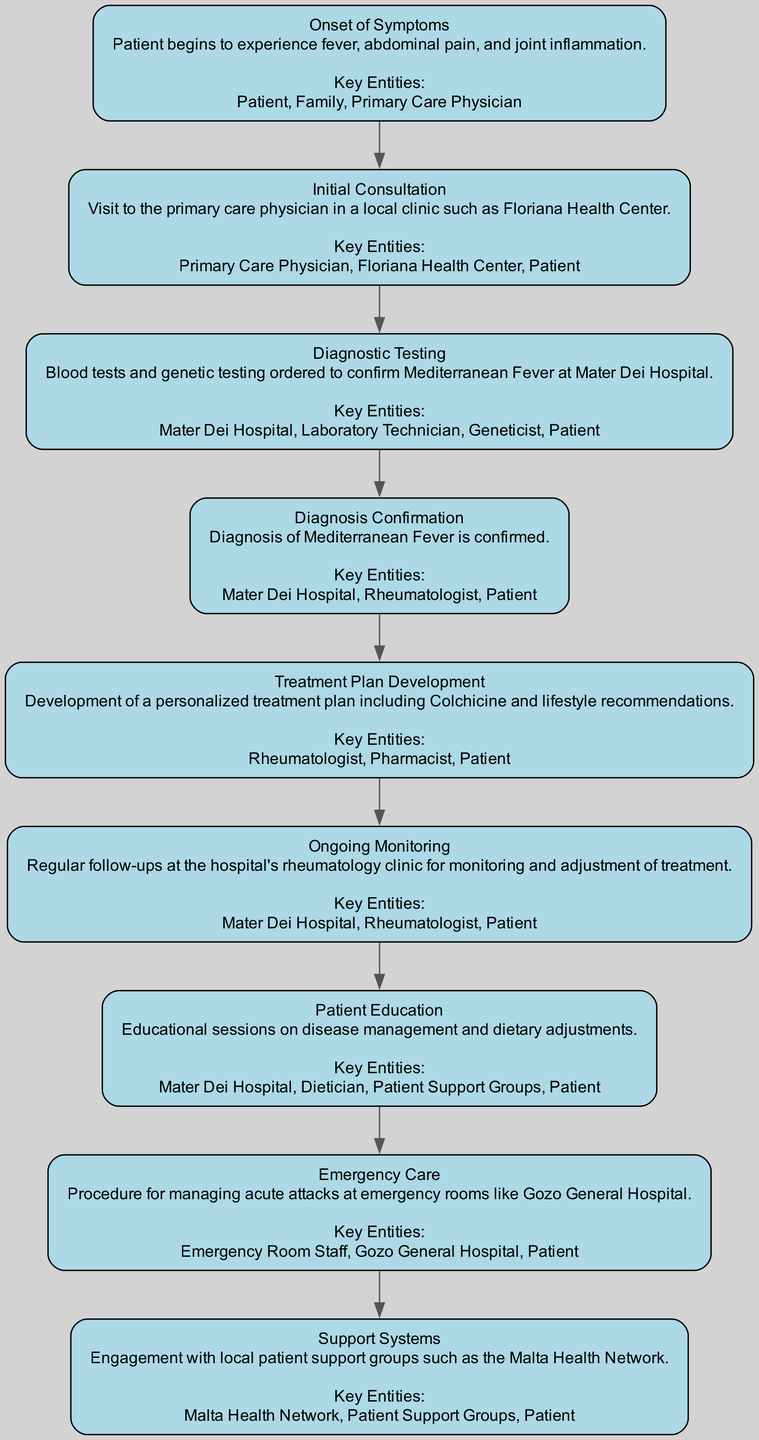What is the first step in the patient's journey? The first step listed in the diagram is "Onset of Symptoms," which describes the initial stage where the patient begins to experience fever, abdominal pain, and joint inflammation.
Answer: Onset of Symptoms How many key entities are involved in the "Initial Consultation"? The "Initial Consultation" stage mentions three key entities: the Primary Care Physician, Floriana Health Center, and Patient. Counting these entities gives a total of three.
Answer: 3 What is the diagnosis confirmed in the fourth stage? The fourth stage, "Diagnosis Confirmation," states that the diagnosis confirmed is Mediterranean Fever, referencing this specific condition.
Answer: Mediterranean Fever Which hospital is mentioned for diagnostic testing? The description in the "Diagnostic Testing" stage indicates that the blood tests and genetic testing are ordered at Mater Dei Hospital.
Answer: Mater Dei Hospital What is the main treatment mentioned in the "Treatment Plan Development"? The "Treatment Plan Development" stage specifically mentions Colchicine as the primary treatment included in the personalized treatment plan.
Answer: Colchicine In which step is patient education emphasized? The step emphasizing patient education is titled "Patient Education," where educational sessions on disease management and dietary adjustments are highlighted.
Answer: Patient Education What is the last stage concerning support systems? The final stage listed in the diagram regarding support is titled "Support Systems," which details the engagement with local patient support groups.
Answer: Support Systems How many total stages are outlined in this clinical pathway? By counting each of the eight stages listed in the diagram, the total number of stages is eight.
Answer: 8 What type of medical professional is involved in the treatment planning? The key entity involved in the treatment planning, as mentioned in the "Treatment Plan Development" stage, is the Rheumatologist, indicating their role in developing the treatment plan.
Answer: Rheumatologist 